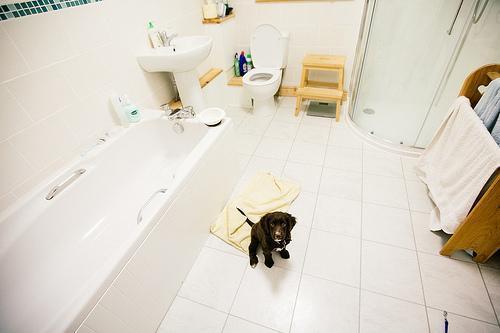How many puppies are pictured?
Give a very brief answer. 1. 